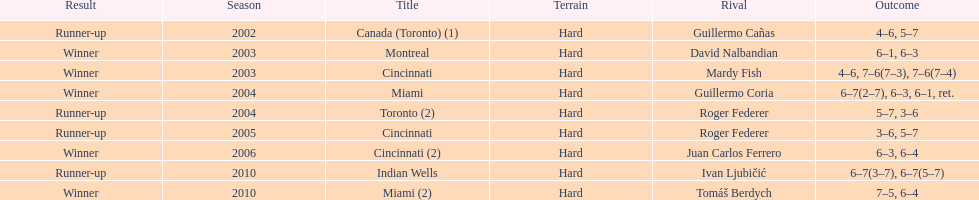How many times has he been runner-up? 4. Could you parse the entire table as a dict? {'header': ['Result', 'Season', 'Title', 'Terrain', 'Rival', 'Outcome'], 'rows': [['Runner-up', '2002', 'Canada (Toronto) (1)', 'Hard', 'Guillermo Cañas', '4–6, 5–7'], ['Winner', '2003', 'Montreal', 'Hard', 'David Nalbandian', '6–1, 6–3'], ['Winner', '2003', 'Cincinnati', 'Hard', 'Mardy Fish', '4–6, 7–6(7–3), 7–6(7–4)'], ['Winner', '2004', 'Miami', 'Hard', 'Guillermo Coria', '6–7(2–7), 6–3, 6–1, ret.'], ['Runner-up', '2004', 'Toronto (2)', 'Hard', 'Roger Federer', '5–7, 3–6'], ['Runner-up', '2005', 'Cincinnati', 'Hard', 'Roger Federer', '3–6, 5–7'], ['Winner', '2006', 'Cincinnati (2)', 'Hard', 'Juan Carlos Ferrero', '6–3, 6–4'], ['Runner-up', '2010', 'Indian Wells', 'Hard', 'Ivan Ljubičić', '6–7(3–7), 6–7(5–7)'], ['Winner', '2010', 'Miami (2)', 'Hard', 'Tomáš Berdych', '7–5, 6–4']]} 